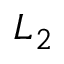Convert formula to latex. <formula><loc_0><loc_0><loc_500><loc_500>L _ { 2 }</formula> 